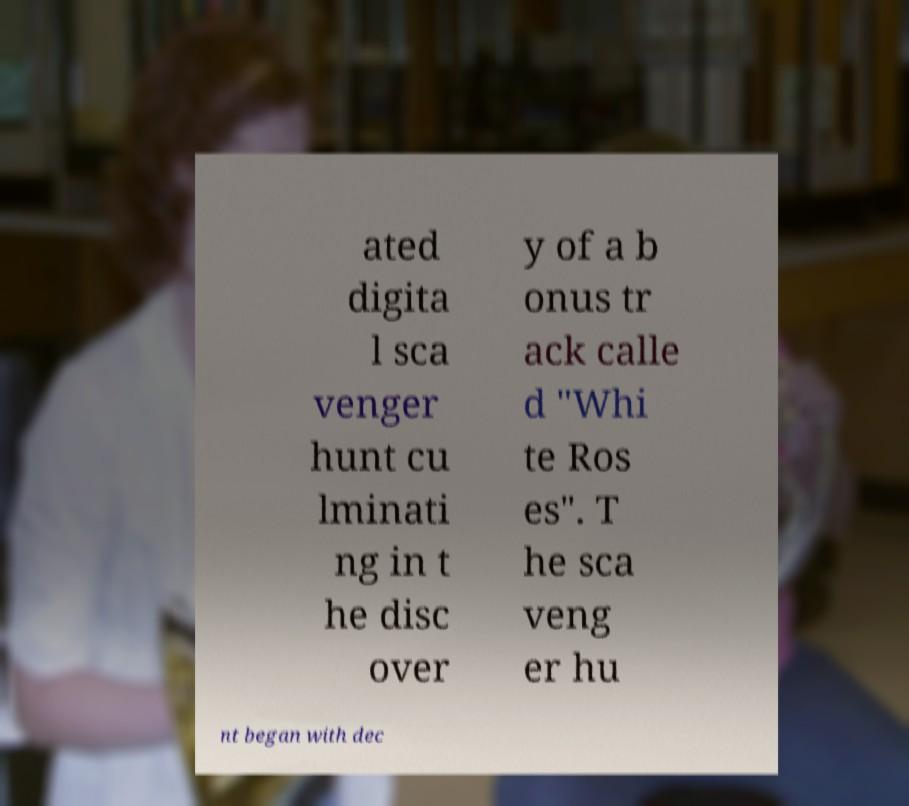Can you read and provide the text displayed in the image?This photo seems to have some interesting text. Can you extract and type it out for me? ated digita l sca venger hunt cu lminati ng in t he disc over y of a b onus tr ack calle d "Whi te Ros es". T he sca veng er hu nt began with dec 